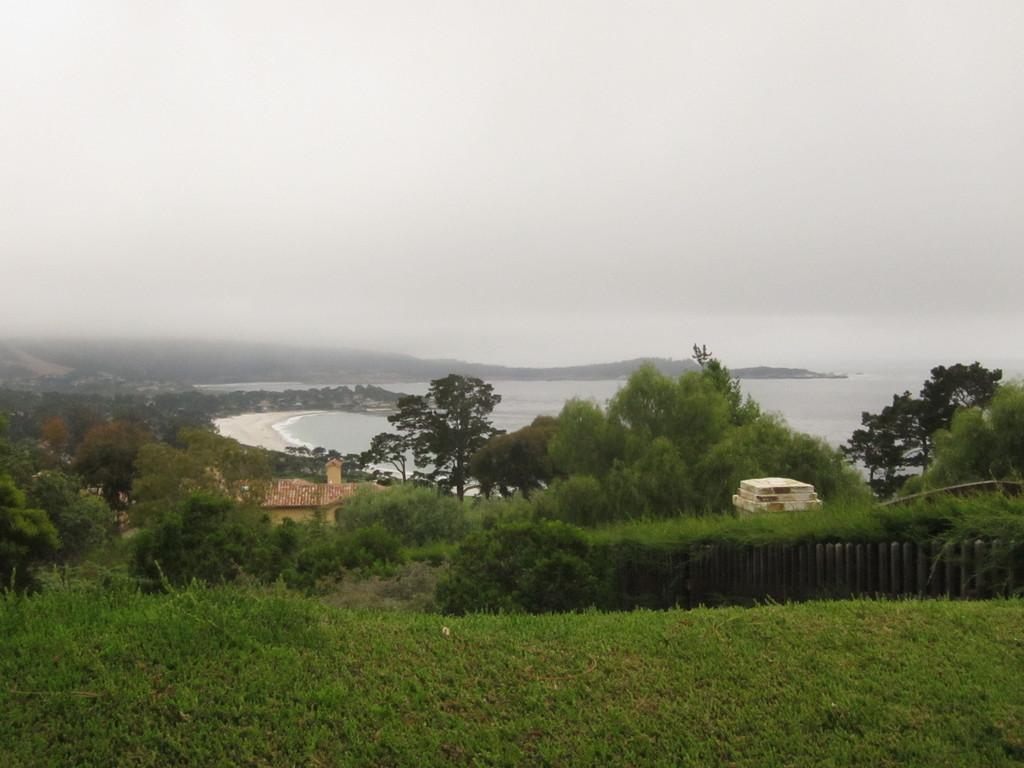What type of barrier can be seen in the image? There is a fence in the image. What type of vegetation is present in the image? There is grass and trees in the image. What natural element is visible in the image? There is water visible in the image. What type of structure is present in the image? There is a house in the image. What type of ground surface is present in the image? There are stones in the image. What part of the natural environment is visible in the image? The sky is visible in the image. What type of fold can be seen in the image? There is no fold present in the image. What type of scientific experiment is being conducted in the image? There is no scientific experiment being conducted in the image. 